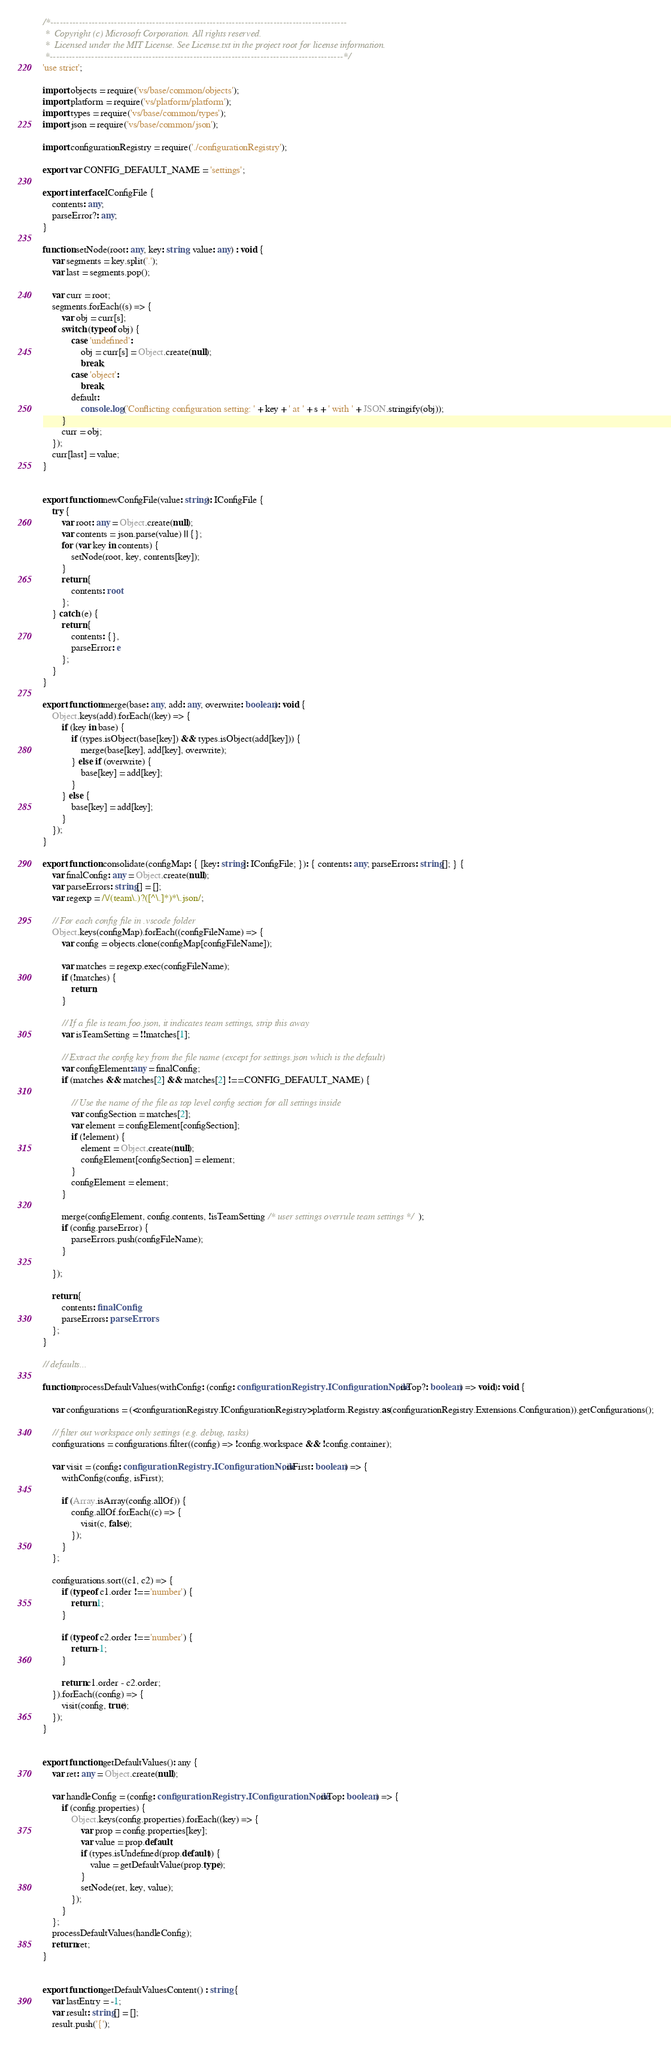Convert code to text. <code><loc_0><loc_0><loc_500><loc_500><_TypeScript_>/*---------------------------------------------------------------------------------------------
 *  Copyright (c) Microsoft Corporation. All rights reserved.
 *  Licensed under the MIT License. See License.txt in the project root for license information.
 *--------------------------------------------------------------------------------------------*/
'use strict';

import objects = require('vs/base/common/objects');
import platform = require('vs/platform/platform');
import types = require('vs/base/common/types');
import json = require('vs/base/common/json');

import configurationRegistry = require('./configurationRegistry');

export var CONFIG_DEFAULT_NAME = 'settings';

export interface IConfigFile {
	contents: any;
	parseError?: any;
}

function setNode(root: any, key: string, value: any) : void {
	var segments = key.split('.');
	var last = segments.pop();

	var curr = root;
	segments.forEach((s) => {
		var obj = curr[s];
		switch (typeof obj) {
			case 'undefined':
				obj = curr[s] = Object.create(null);
				break;
			case 'object':
				break;
			default:
				console.log('Conflicting configuration setting: ' + key + ' at ' + s + ' with ' + JSON.stringify(obj));
		}
		curr = obj;
	});
	curr[last] = value;
}


export function newConfigFile(value: string): IConfigFile {
	try {
		var root: any = Object.create(null);
		var contents = json.parse(value) || {};
		for (var key in contents) {
			setNode(root, key, contents[key]);
		}
		return {
			contents: root
		};
	} catch (e) {
		return {
			contents: {},
			parseError: e
		};
	}
}

export function merge(base: any, add: any, overwrite: boolean): void {
	Object.keys(add).forEach((key) => {
		if (key in base) {
			if (types.isObject(base[key]) && types.isObject(add[key])) {
				merge(base[key], add[key], overwrite);
			} else if (overwrite) {
				base[key] = add[key];
			}
		} else {
			base[key] = add[key];
		}
	});
}

export function consolidate(configMap: { [key: string]: IConfigFile; }): { contents: any; parseErrors: string[]; } {
	var finalConfig: any = Object.create(null);
	var parseErrors: string[] = [];
	var regexp = /\/(team\.)?([^\.]*)*\.json/;

	// For each config file in .vscode folder
	Object.keys(configMap).forEach((configFileName) => {
		var config = objects.clone(configMap[configFileName]);

		var matches = regexp.exec(configFileName);
		if (!matches) {
			return;
		}

		// If a file is team.foo.json, it indicates team settings, strip this away
		var isTeamSetting = !!matches[1];

		// Extract the config key from the file name (except for settings.json which is the default)
		var configElement:any = finalConfig;
		if (matches && matches[2] && matches[2] !== CONFIG_DEFAULT_NAME) {

			// Use the name of the file as top level config section for all settings inside
			var configSection = matches[2];
			var element = configElement[configSection];
			if (!element) {
				element = Object.create(null);
				configElement[configSection] = element;
			}
			configElement = element;
		}

		merge(configElement, config.contents, !isTeamSetting /* user settings overrule team settings */);
		if (config.parseError) {
			parseErrors.push(configFileName);
		}

	});

	return {
		contents: finalConfig,
		parseErrors: parseErrors
	};
}

// defaults...

function processDefaultValues(withConfig: (config: configurationRegistry.IConfigurationNode, isTop?: boolean) => void): void {

	var configurations = (<configurationRegistry.IConfigurationRegistry>platform.Registry.as(configurationRegistry.Extensions.Configuration)).getConfigurations();

	// filter out workspace only settings (e.g. debug, tasks)
	configurations = configurations.filter((config) => !config.workspace && !config.container);

	var visit = (config: configurationRegistry.IConfigurationNode, isFirst: boolean) => {
		withConfig(config, isFirst);

		if (Array.isArray(config.allOf)) {
			config.allOf.forEach((c) => {
				visit(c, false);
			});
		}
	};

	configurations.sort((c1, c2) => {
		if (typeof c1.order !== 'number') {
			return 1;
		}

		if (typeof c2.order !== 'number') {
			return -1;
		}

		return c1.order - c2.order;
	}).forEach((config) => {
		visit(config, true);
	});
}


export function getDefaultValues(): any {
	var ret: any = Object.create(null);

	var handleConfig = (config: configurationRegistry.IConfigurationNode, isTop: boolean) => {
		if (config.properties) {
			Object.keys(config.properties).forEach((key) => {
				var prop = config.properties[key];
				var value = prop.default;
				if (types.isUndefined(prop.default)) {
					value = getDefaultValue(prop.type);
				}
				setNode(ret, key, value);
			});
		}
	};
	processDefaultValues(handleConfig);
	return ret;
}


export function getDefaultValuesContent() : string {
	var lastEntry = -1;
	var result: string[] = [];
	result.push('{');
</code> 